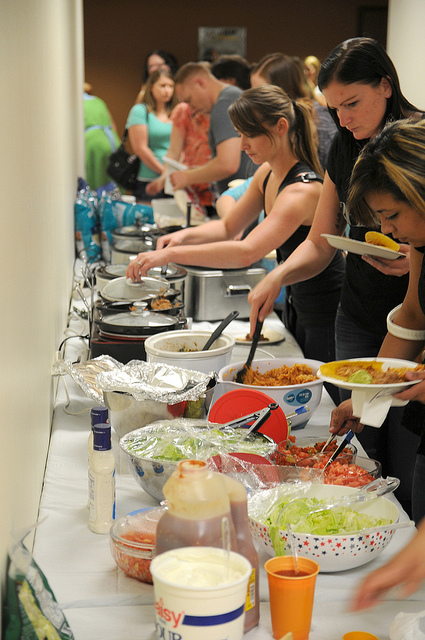What kinds of food can you see on the table? There are several dishes visible on the table, including what appears to be a large bowl of salad with various toppings, a pasta dish, and possibly some tacos or tortilla-wrapped food. Additionally, there seem to be some condiments and a fruit tray further down. 